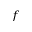Convert formula to latex. <formula><loc_0><loc_0><loc_500><loc_500>_ { f }</formula> 